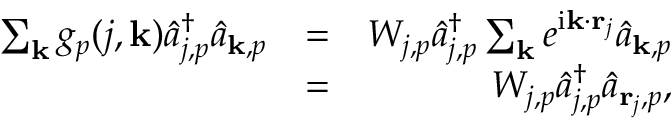Convert formula to latex. <formula><loc_0><loc_0><loc_500><loc_500>\begin{array} { r l r } { \sum _ { k } g _ { p } ( j , { k } ) \hat { a } _ { j , p } ^ { \dagger } \hat { a } _ { { k } , p } } & { = } & { W _ { j , p } \hat { a } _ { j , p } ^ { \dagger } \sum _ { k } e ^ { i { k } \cdot { r } _ { j } } \hat { a } _ { { k } , p } } \\ & { = } & { W _ { j , p } \hat { a } _ { j , p } ^ { \dagger } \hat { a } _ { { r } _ { j } , p } , } \end{array}</formula> 